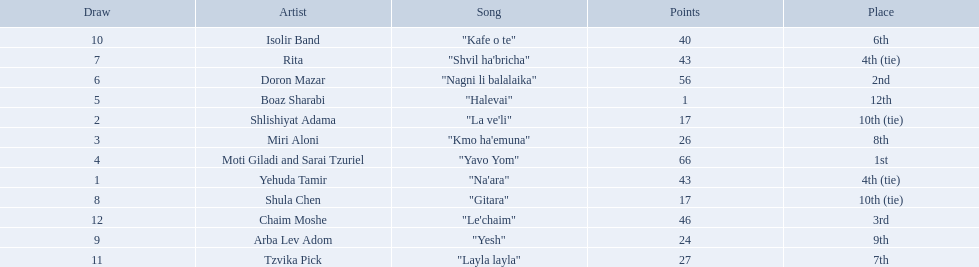What are the points in the competition? 43, 17, 26, 66, 1, 56, 43, 17, 24, 40, 27, 46. What is the lowest points? 1. What artist received these points? Boaz Sharabi. 